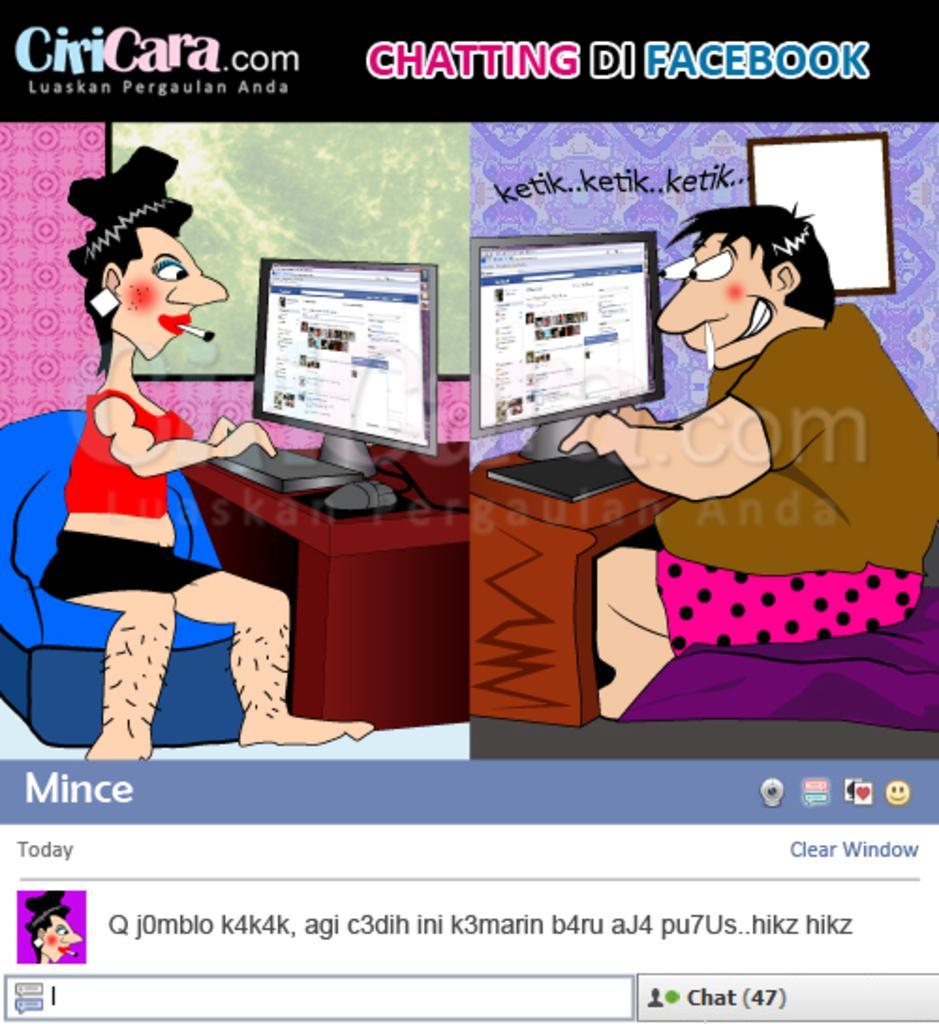How would you summarize this image in a sentence or two? It is the animation image in which there is a man sitting on the right side and using the computer. On the left side there is a woman who is using the keyboard. She is having a cigar in her mouth. In the background there is a wall on which there is some design. At the bottom there is some text. 